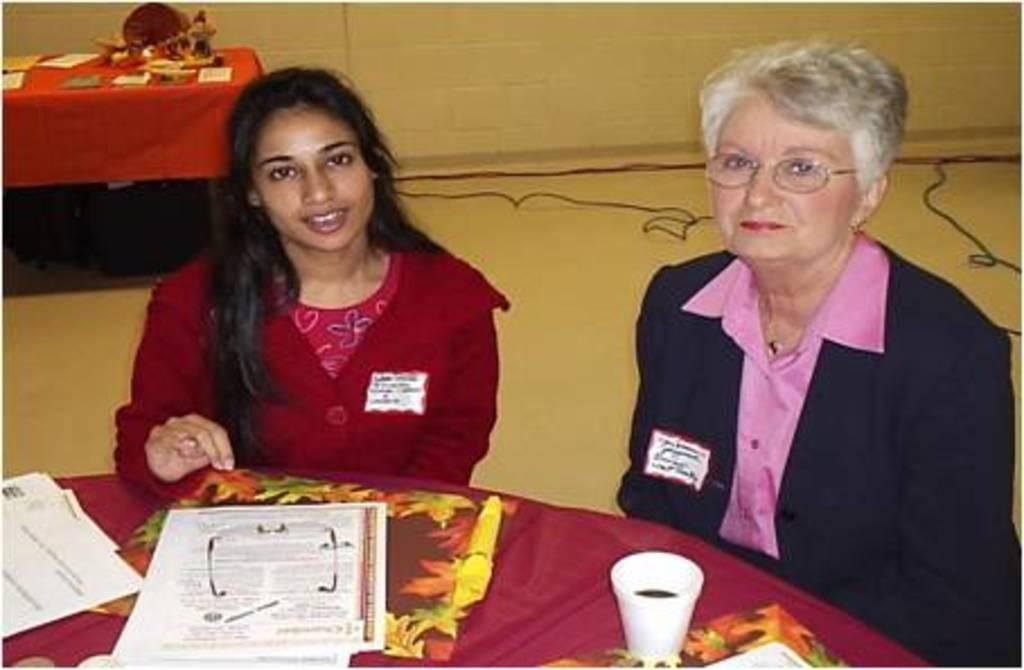How many women are in the image? There are two women in the image. What are the women doing in the image? The women are sitting on chairs. What is in front of the women? There is a table in front of the women. What objects can be seen on the table? There is a glass, a paper, and spectacles on the table. Are there any spectacles on the floor? Yes, there are spectacles on the floor. What suggestion does the bat make to the women in the image? There is no bat present in the image, so it cannot make any suggestions to the women. 